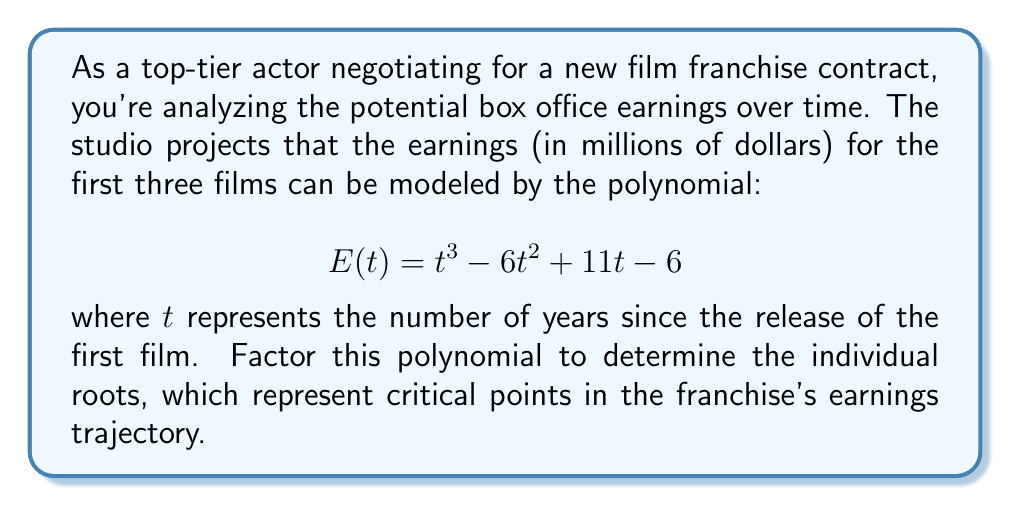Give your solution to this math problem. To factor this cubic polynomial, we'll follow these steps:

1) First, let's check if there's a rational root. We can use the rational root theorem to list possible roots: ±1, ±2, ±3, ±6

2) By testing these values, we find that $t = 1$ is a root. So $(t - 1)$ is a factor.

3) We can use polynomial long division to find the other factor:

   $$\frac{t^3 - 6t^2 + 11t - 6}{t - 1} = t^2 - 5t + 6$$

4) Now our polynomial is factored as: $E(t) = (t - 1)(t^2 - 5t + 6)$

5) The quadratic factor $t^2 - 5t + 6$ can be further factored using the quadratic formula or by recognizing it as the difference of its roots:

   $$t^2 - 5t + 6 = (t - 2)(t - 3)$$

6) Therefore, the fully factored polynomial is:

   $$E(t) = (t - 1)(t - 2)(t - 3)$$

The roots of this polynomial (1, 2, and 3) represent critical years in the franchise's earnings trajectory, which could be valuable information for contract negotiations.
Answer: $$E(t) = (t - 1)(t - 2)(t - 3)$$ 